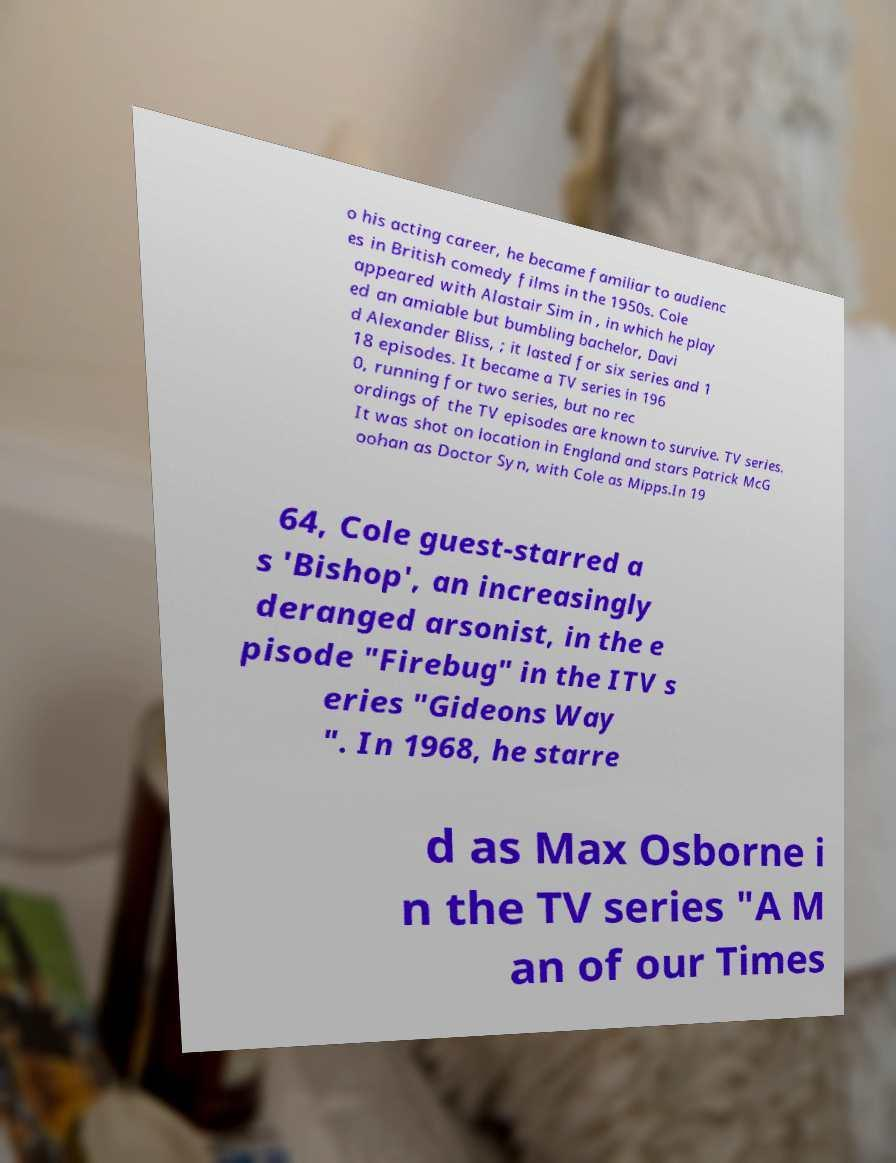For documentation purposes, I need the text within this image transcribed. Could you provide that? o his acting career, he became familiar to audienc es in British comedy films in the 1950s. Cole appeared with Alastair Sim in , in which he play ed an amiable but bumbling bachelor, Davi d Alexander Bliss, ; it lasted for six series and 1 18 episodes. It became a TV series in 196 0, running for two series, but no rec ordings of the TV episodes are known to survive. TV series. It was shot on location in England and stars Patrick McG oohan as Doctor Syn, with Cole as Mipps.In 19 64, Cole guest-starred a s 'Bishop', an increasingly deranged arsonist, in the e pisode "Firebug" in the ITV s eries "Gideons Way ". In 1968, he starre d as Max Osborne i n the TV series "A M an of our Times 